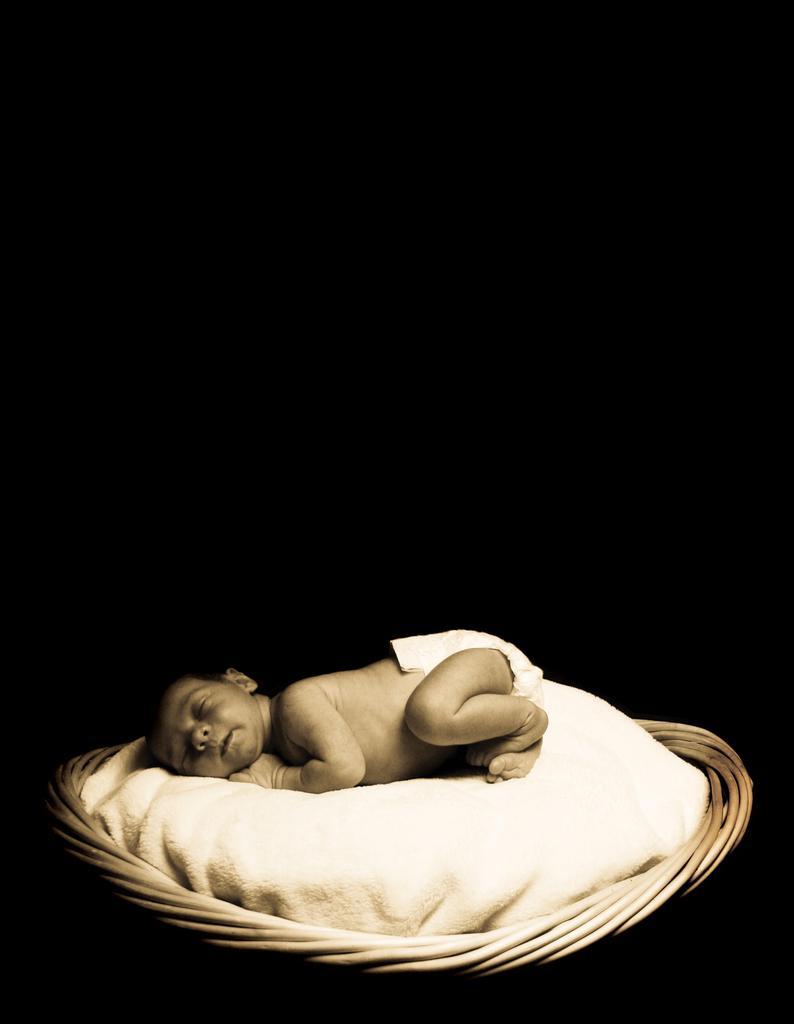In one or two sentences, can you explain what this image depicts? In this picture I can see a baby lying and I can see a cloth and it looks like a basket and I can see dark background. 